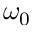<formula> <loc_0><loc_0><loc_500><loc_500>\omega _ { 0 }</formula> 